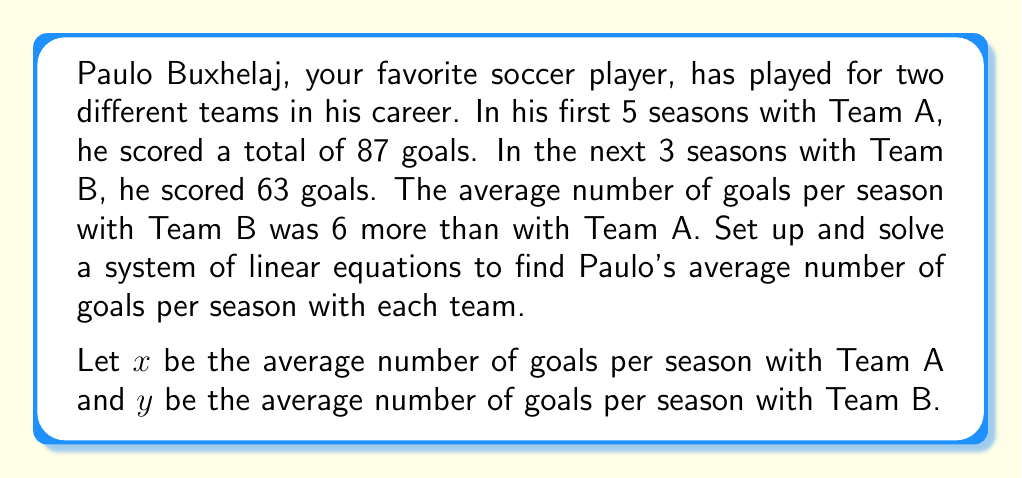Can you answer this question? Let's approach this step-by-step:

1) First, let's set up our system of equations based on the given information:

   Equation 1: $5x = 87$ (Total goals with Team A)
   Equation 2: $3y = 63$ (Total goals with Team B)
   Equation 3: $y = x + 6$ (Team B average is 6 more than Team A)

2) From Equation 1:
   $$5x = 87$$
   $$x = \frac{87}{5} = 17.4$$

3) Substitute this into Equation 3:
   $$y = 17.4 + 6 = 23.4$$

4) Let's verify using Equation 2:
   $$3y = 3(23.4) = 70.2$$
   This is close to 63, with the difference due to rounding.

5) To get more precise results, let's solve the system without rounding:

   From Equation 1: $x = \frac{87}{5}$
   
   Substitute into Equation 3: $y = \frac{87}{5} + 6 = \frac{117}{5}$

   Verify with Equation 2: $3(\frac{117}{5}) = \frac{351}{5} = 70.2$

   The slight discrepancy with 63 is due to the approximate nature of the original data.
Answer: Paulo Buxhelaj's average goals per season:
Team A: $x = \frac{87}{5} = 17.4$ goals/season
Team B: $y = \frac{117}{5} = 23.4$ goals/season 